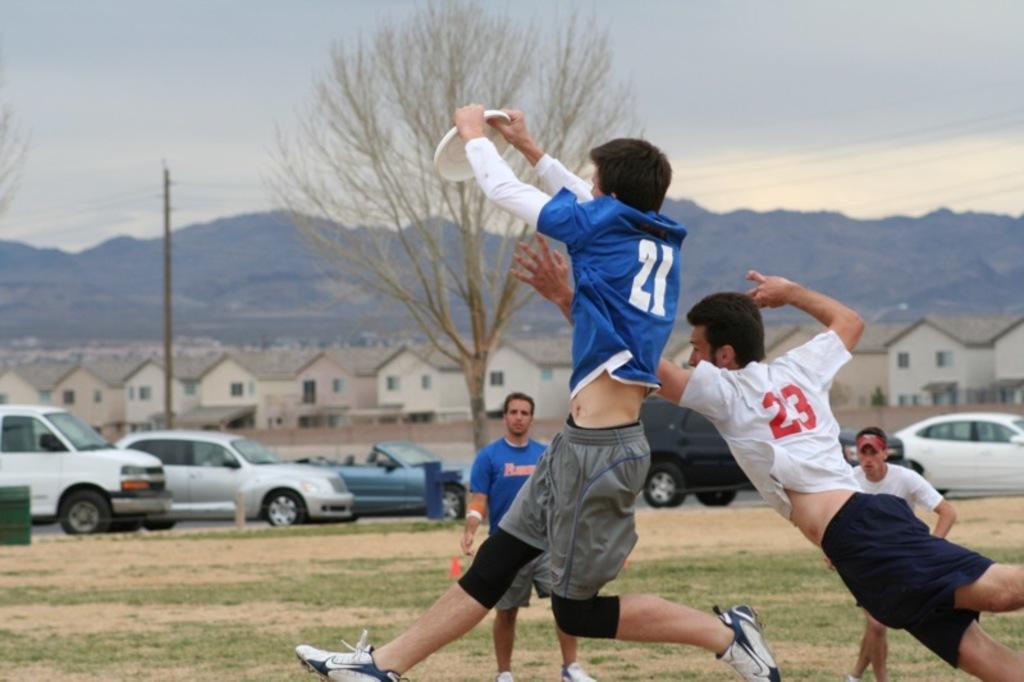Can you describe this image briefly? In this picture we can see 4 people playing Frisbee on the grass area. In the background, we can see vehicles on the road. We can see houses and mountains. The sky is gloomy. 